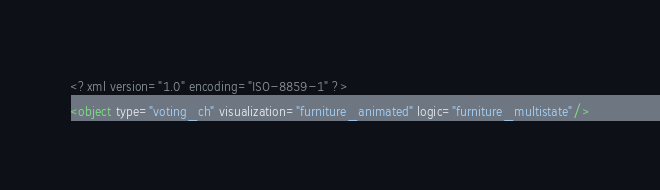Convert code to text. <code><loc_0><loc_0><loc_500><loc_500><_XML_><?xml version="1.0" encoding="ISO-8859-1" ?>
<object type="voting_ch" visualization="furniture_animated" logic="furniture_multistate"/>
</code> 